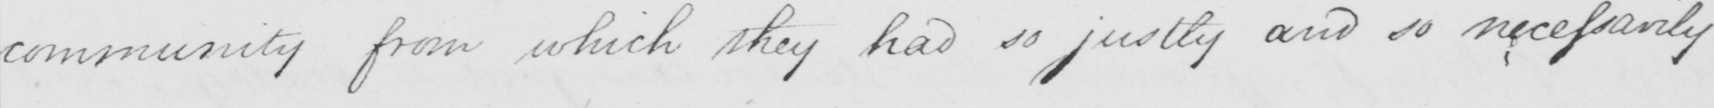Please provide the text content of this handwritten line. community from which they had so justly and so necessarily 